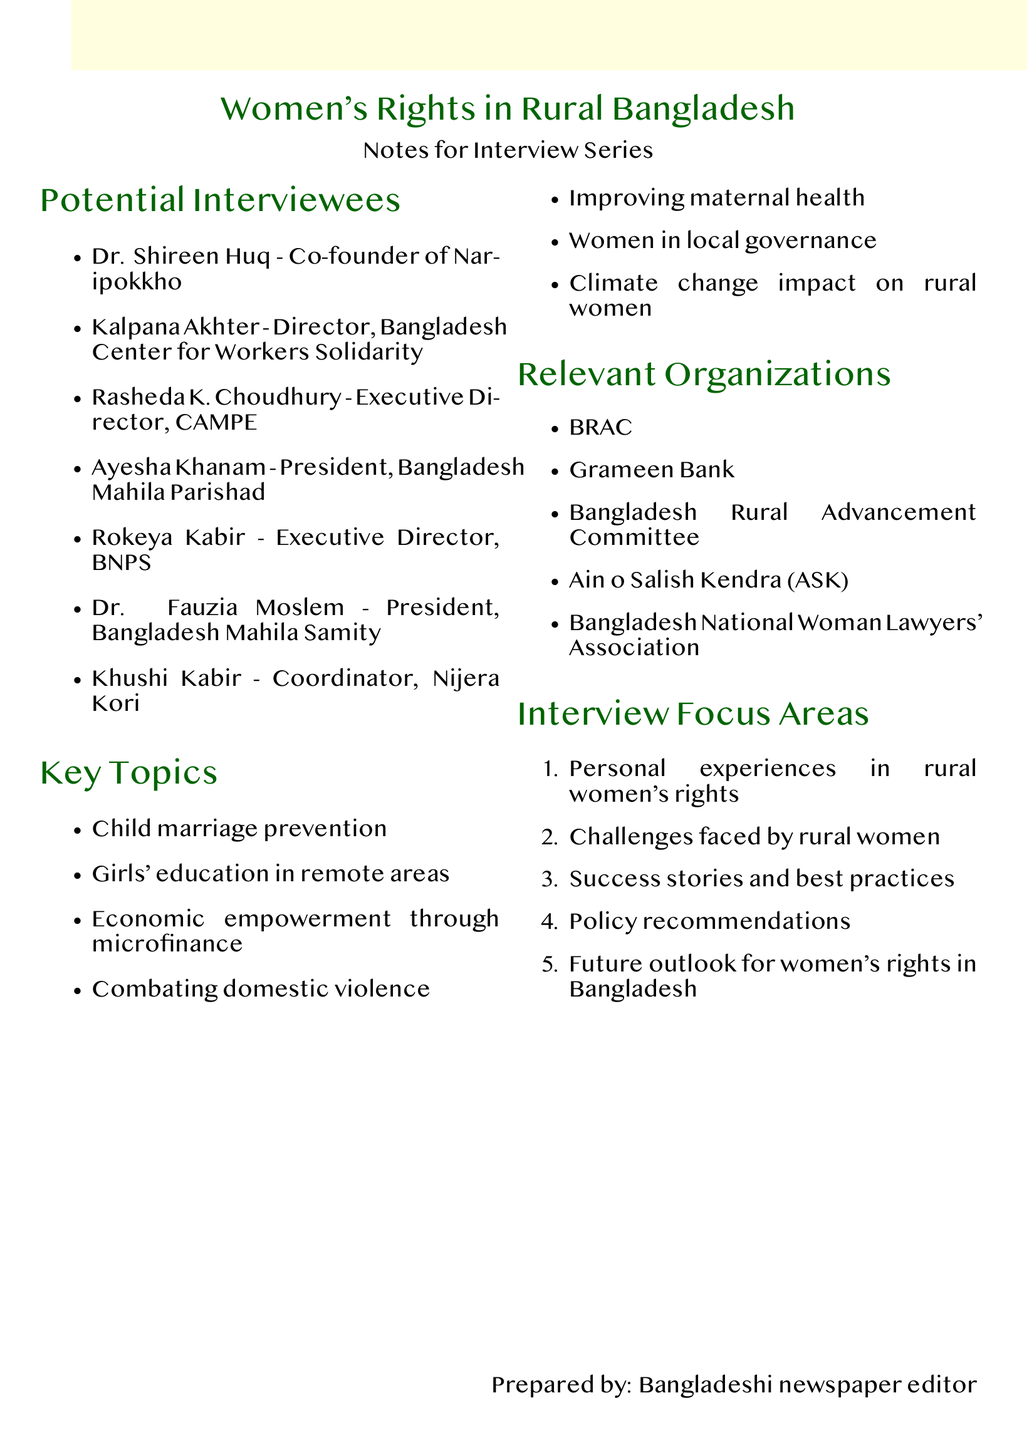What organization did Dr. Shireen Huq co-found? Dr. Shireen Huq is the co-founder of Naripokkho, a women's rights organization mentioned in the document.
Answer: Naripokkho Who is the Director of the Bangladesh Center for Workers Solidarity? Kalpana Akhter is specified as the Director of the Bangladesh Center for Workers Solidarity in the document.
Answer: Kalpana Akhter What key topic addresses the issue of early marriage? The document lists "Child marriage prevention in rural areas" as one of the key topics.
Answer: Child marriage prevention Which organization focuses on women's economic empowerment? The document mentions Bangladesh Nari Progati Sangha (BNPS) as focused on women's economic empowerment.
Answer: BNPS How many potential interviewees are listed? The document lists a total of seven potential interviewees for the series on women's rights.
Answer: Seven What is one of the key topics related to healthcare? "Improving maternal health and access to healthcare" is highlighted as a key topic in the notes.
Answer: Improving maternal health What is a focus area for the interviews? The document outlines several focus areas, one being "Challenges faced by rural women."
Answer: Challenges faced by rural women Who is the executive director of Campaign for Popular Education? Rasheda K. Choudhury is mentioned as the Executive Director of CAMPE in the document.
Answer: Rasheda K. Choudhury Name one relevant organization mentioned in the notes. The document lists BRAC as one of the relevant organizations working in women's rights.
Answer: BRAC 